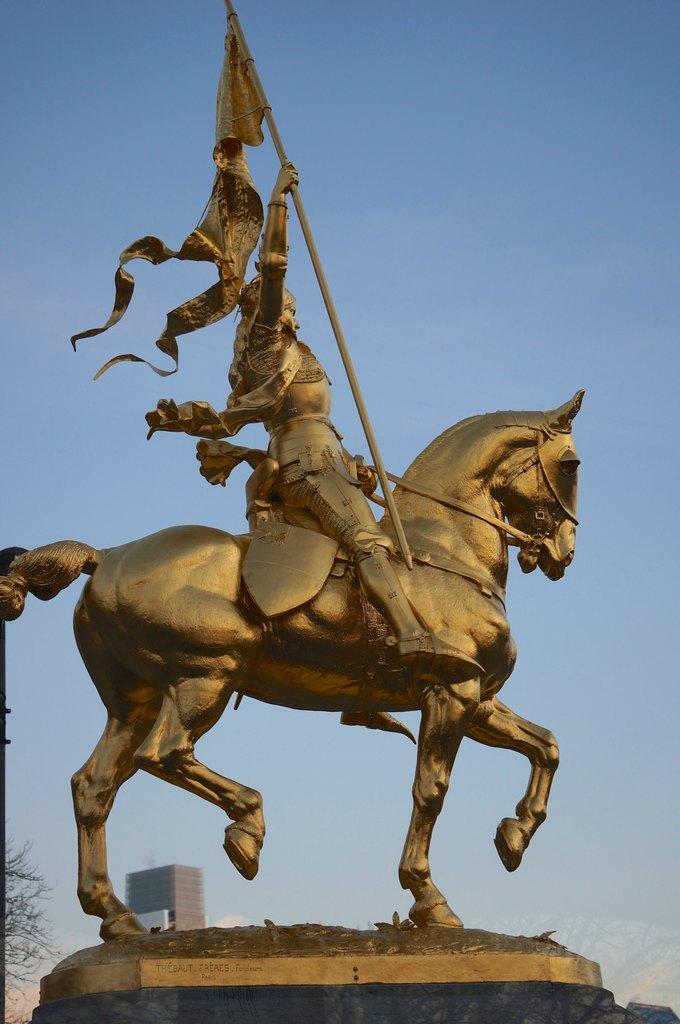What is the main subject of the image? There is a sculpture of a horse in the image. What is the person in the image doing? A person is sitting on the horse sculpture. What is the person holding in the image? The person is holding a pole with a flag. What can be seen in the background of the image? There is a building and the sky visible in the background of the image. What color is the person's attempt to turn the horse sculpture into a real horse? There is no attempt to turn the horse sculpture into a real horse in the image, and therefore no color can be assigned to such an action. 